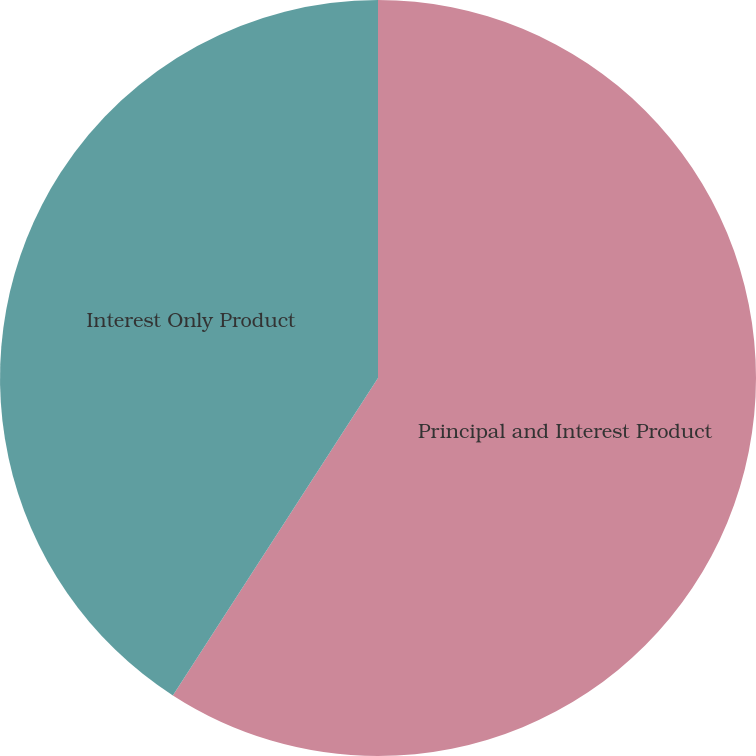Convert chart to OTSL. <chart><loc_0><loc_0><loc_500><loc_500><pie_chart><fcel>Principal and Interest Product<fcel>Interest Only Product<nl><fcel>59.13%<fcel>40.87%<nl></chart> 